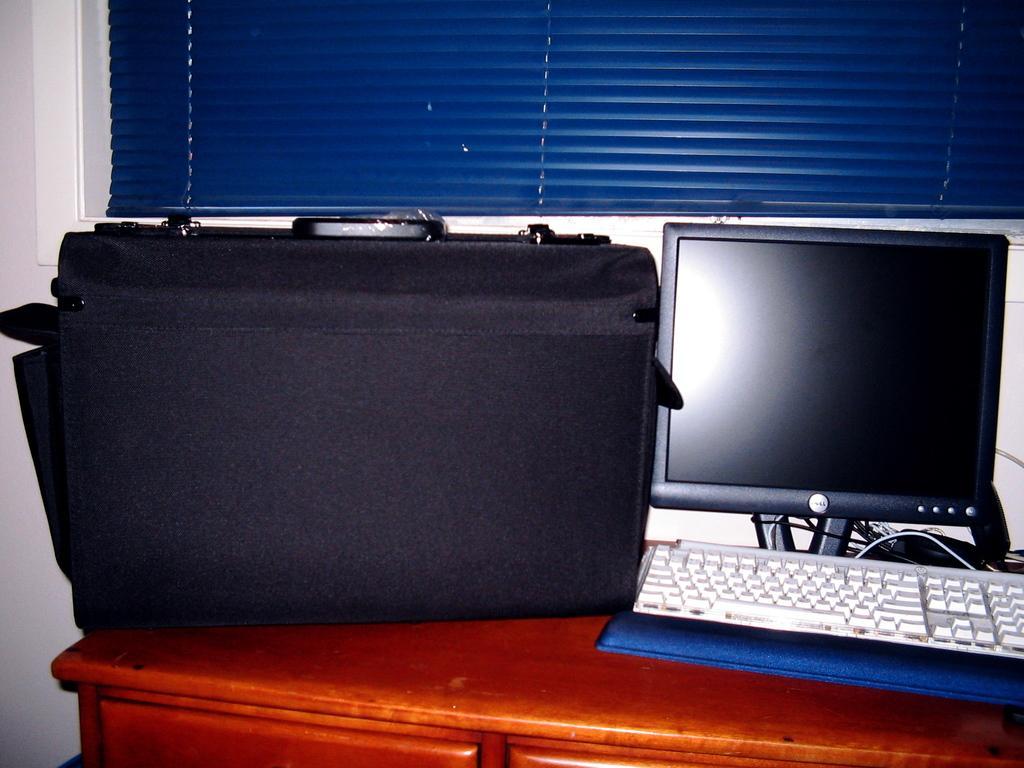Could you give a brief overview of what you see in this image? In this image i can see a bag, a monitor and a keyboard on the table. In the background i can see a wall and the window blind. 